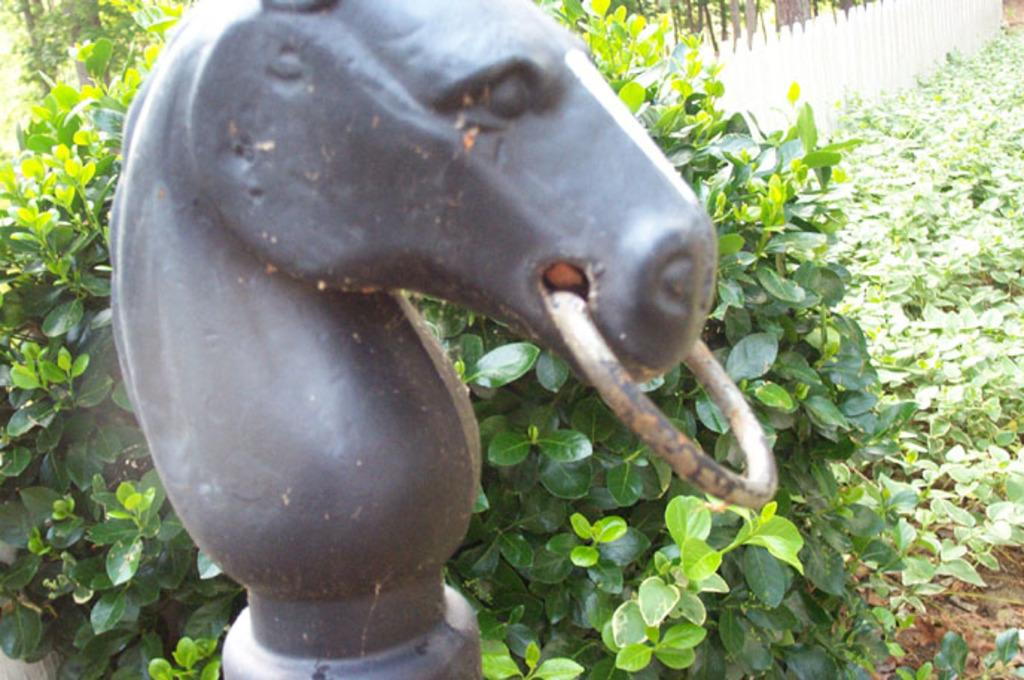What is the main subject in the image? There is a statue in the image. What can be seen in the background of the image? There is a fence and plants in the background of the image. What type of smell can be detected coming from the statue in the image? There is no indication of any smell in the image, as it is a visual medium. 